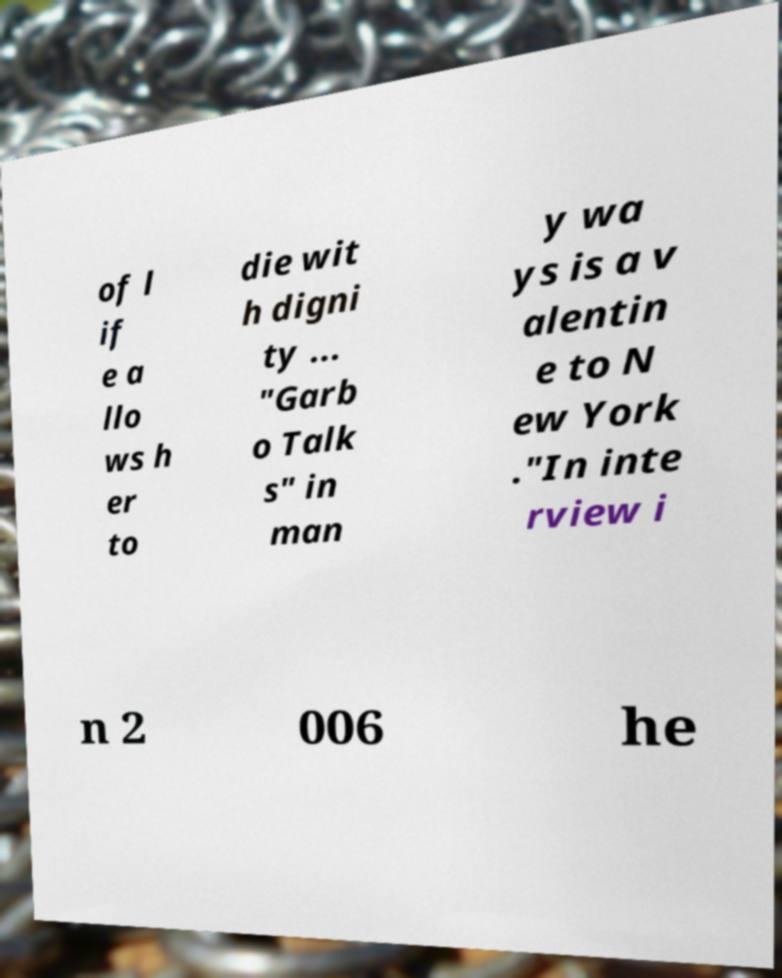Please identify and transcribe the text found in this image. of l if e a llo ws h er to die wit h digni ty ... "Garb o Talk s" in man y wa ys is a v alentin e to N ew York ."In inte rview i n 2 006 he 